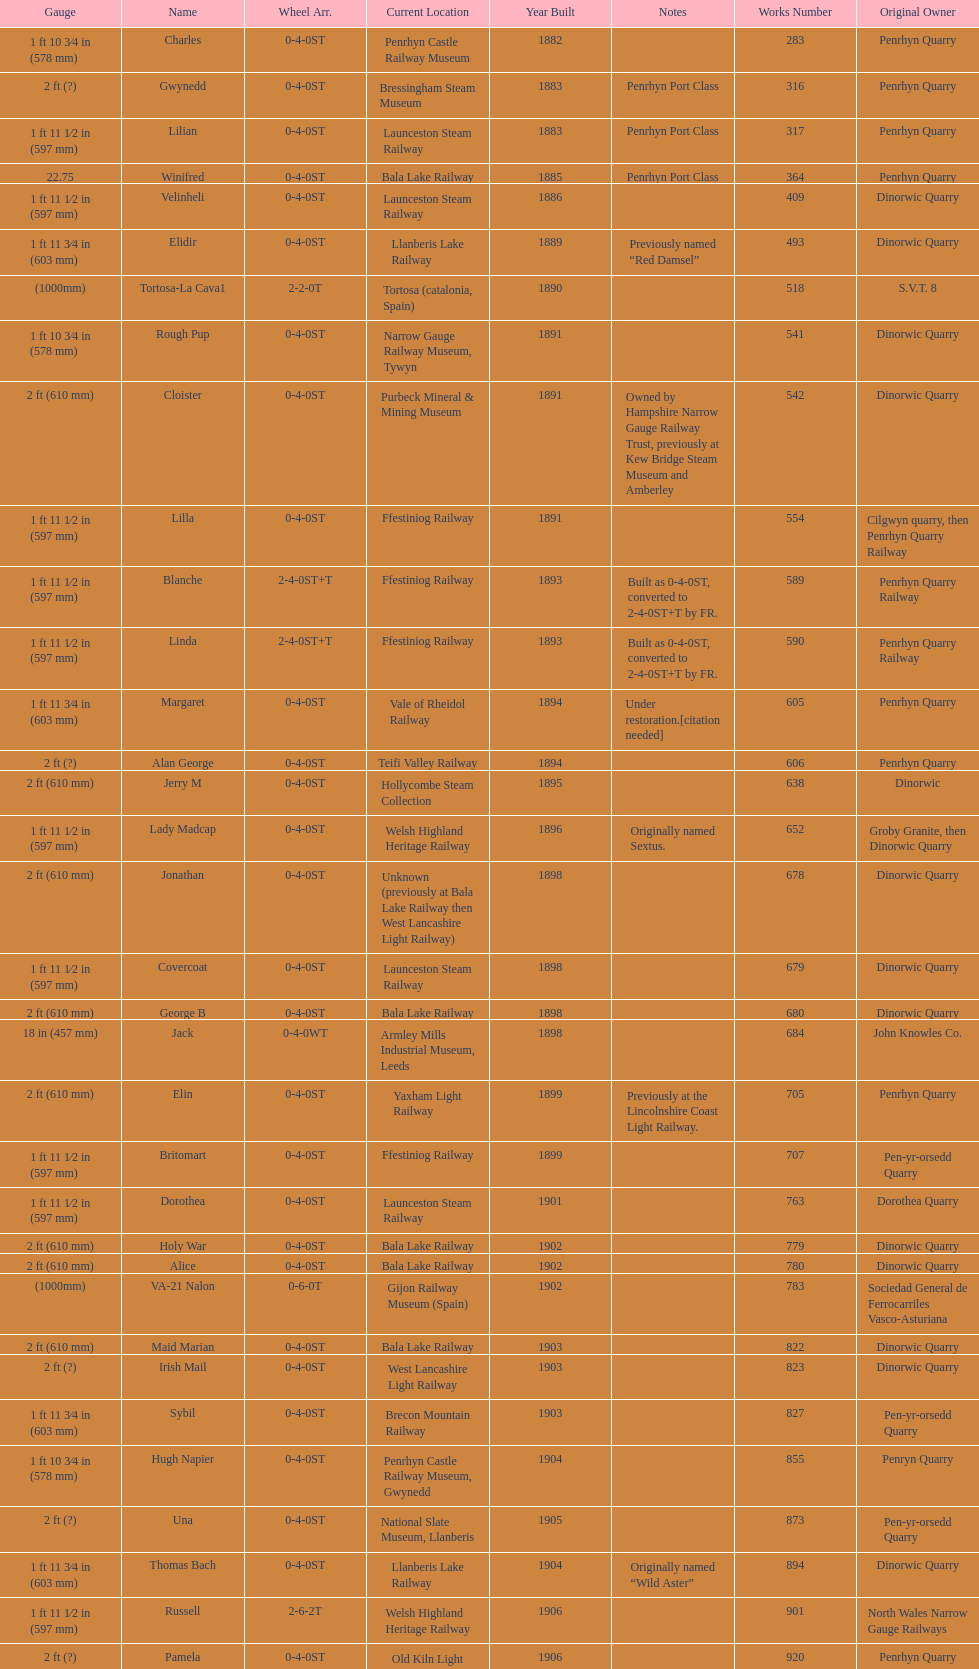What is the difference in gauge between works numbers 541 and 542? 32 mm. 